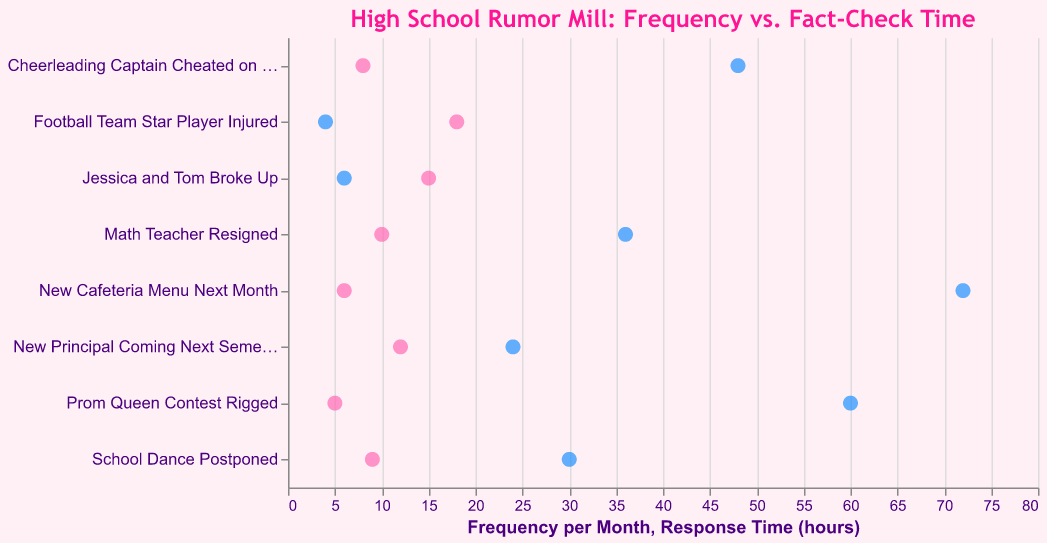how many rumors are plotted on the chart? count each rumor listed on the y-axis. the figure shows 8 rumors, including "jessica and tom broke up" and "prom queen contest rigged".
Answer: 8 which rumor spreads most frequently in the school? identify the rumor with the highest frequency per month on the x-axis. "football team star player injured" has the highest frequency of 18 per month.
Answer: football team star player injured what is the response time for the rumor "cheerleading captain cheated on tests"? locate the rumor on the y-axis, then check the corresponding position on the response time (hours) x-axis. it shows a response time of 48 hours.
Answer: 48 hours how much more frequently is the rumor "football team star player injured" spread compared to "new cafeteria menu next month"? subtract the frequency of "new cafeteria menu next month" (6) from "football team star player injured" (18). it is 18 - 6 = 12.
Answer: 12 which rumor takes the longest to fact-check? look for the rumor with the highest value on the response time (hours) x-axis. "new cafeteria menu next month" takes the longest, 72 hours.
Answer: new cafeteria menu next month what's the total number of hours to fact-check all the listed rumors? sum the response times: 6 + 24 + 48 + 36 + 4 + 30 + 72 + 60 = 280 hours.
Answer: 280 hours is there a rumor that has a higher frequency and lower response time compared to "math teacher resigned"? if so, which one? "math teacher resigned" has a frequency of 10 and a response time of 36 hours. "football team star player injured" has a higher frequency (18) and lower response time (4 hours).
Answer: football team star player injured what is the average frequency per month for the rumors "new principal coming next semester" and "school dance postponed"? add their frequencies (12 + 9), then divide by 2 to get the average. (12 + 9) / 2 = 10.5.
Answer: 10.5 